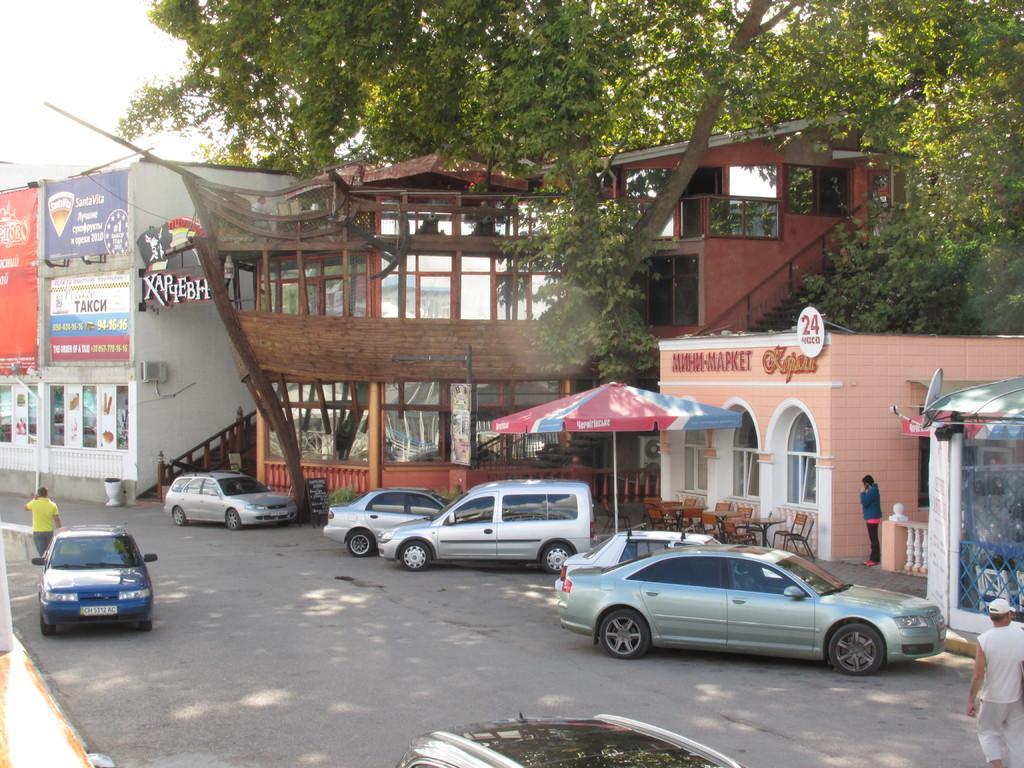Can you describe this image briefly? In this picture there are buildings in the center of the image and there are cars at the bottom side of the image, there are trees at the top side of the image. 